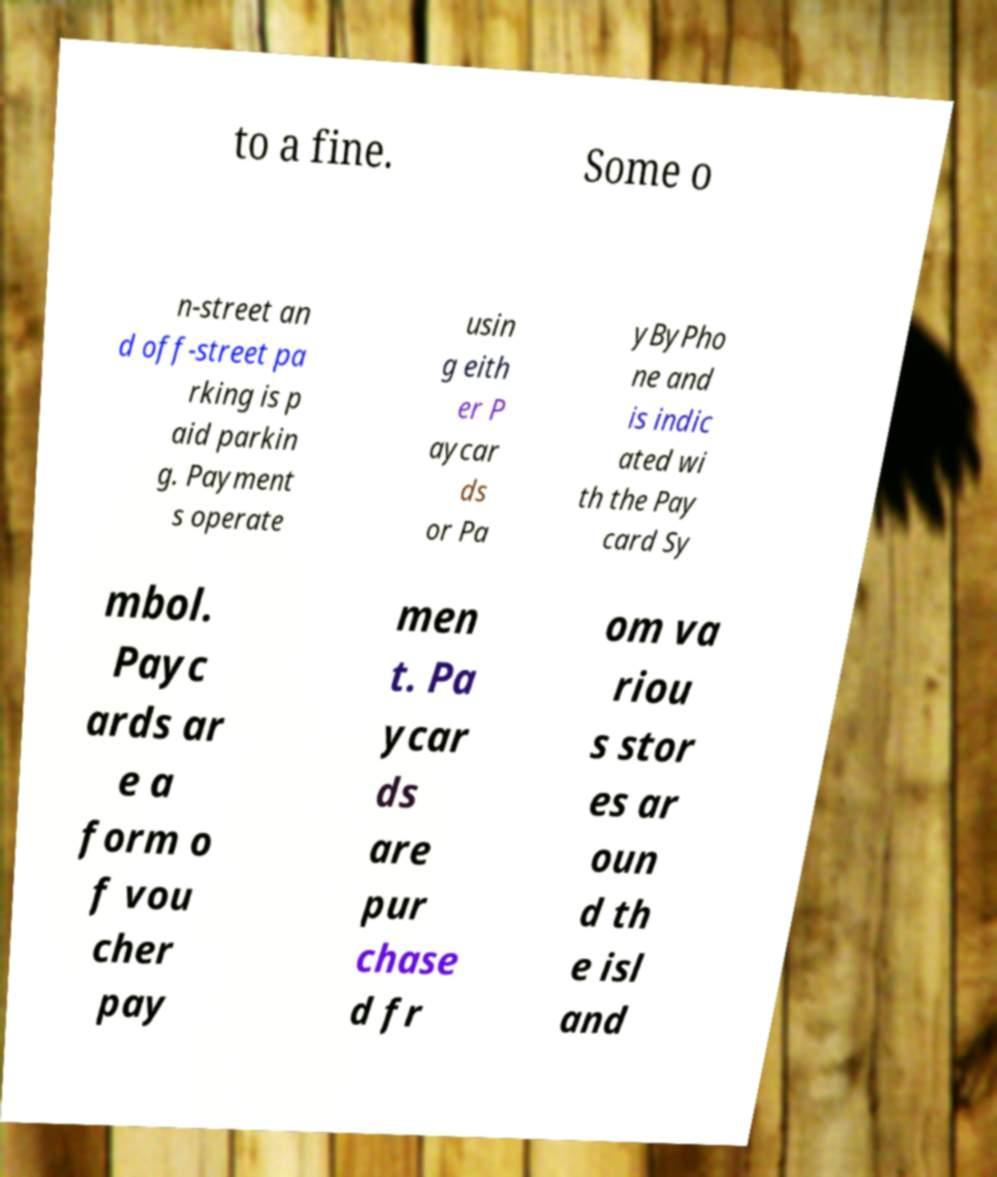There's text embedded in this image that I need extracted. Can you transcribe it verbatim? to a fine. Some o n-street an d off-street pa rking is p aid parkin g. Payment s operate usin g eith er P aycar ds or Pa yByPho ne and is indic ated wi th the Pay card Sy mbol. Payc ards ar e a form o f vou cher pay men t. Pa ycar ds are pur chase d fr om va riou s stor es ar oun d th e isl and 